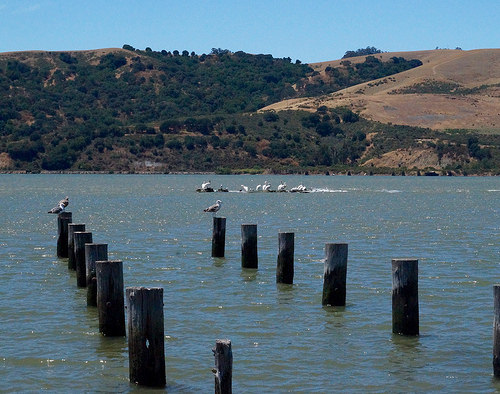<image>
Can you confirm if the sky is behind the land? Yes. From this viewpoint, the sky is positioned behind the land, with the land partially or fully occluding the sky. 